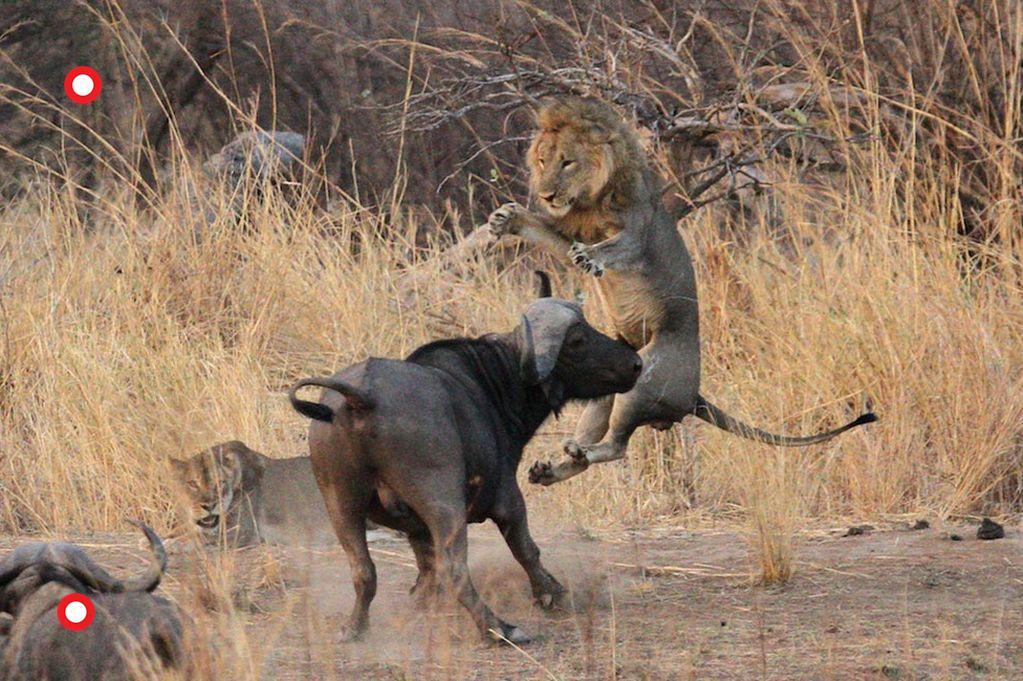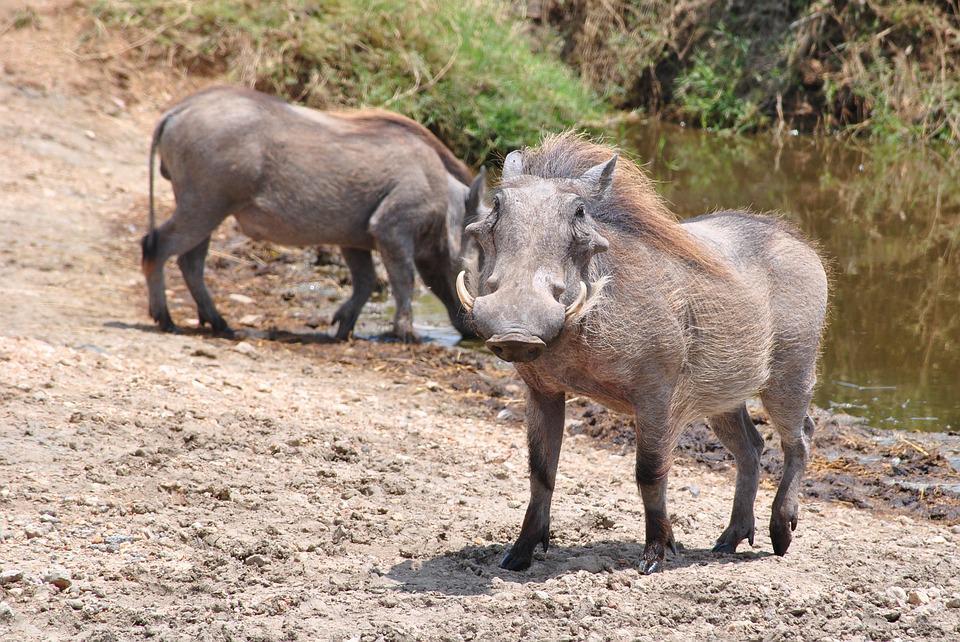The first image is the image on the left, the second image is the image on the right. For the images shown, is this caption "The animals in one of the images are near a wet area." true? Answer yes or no. Yes. 